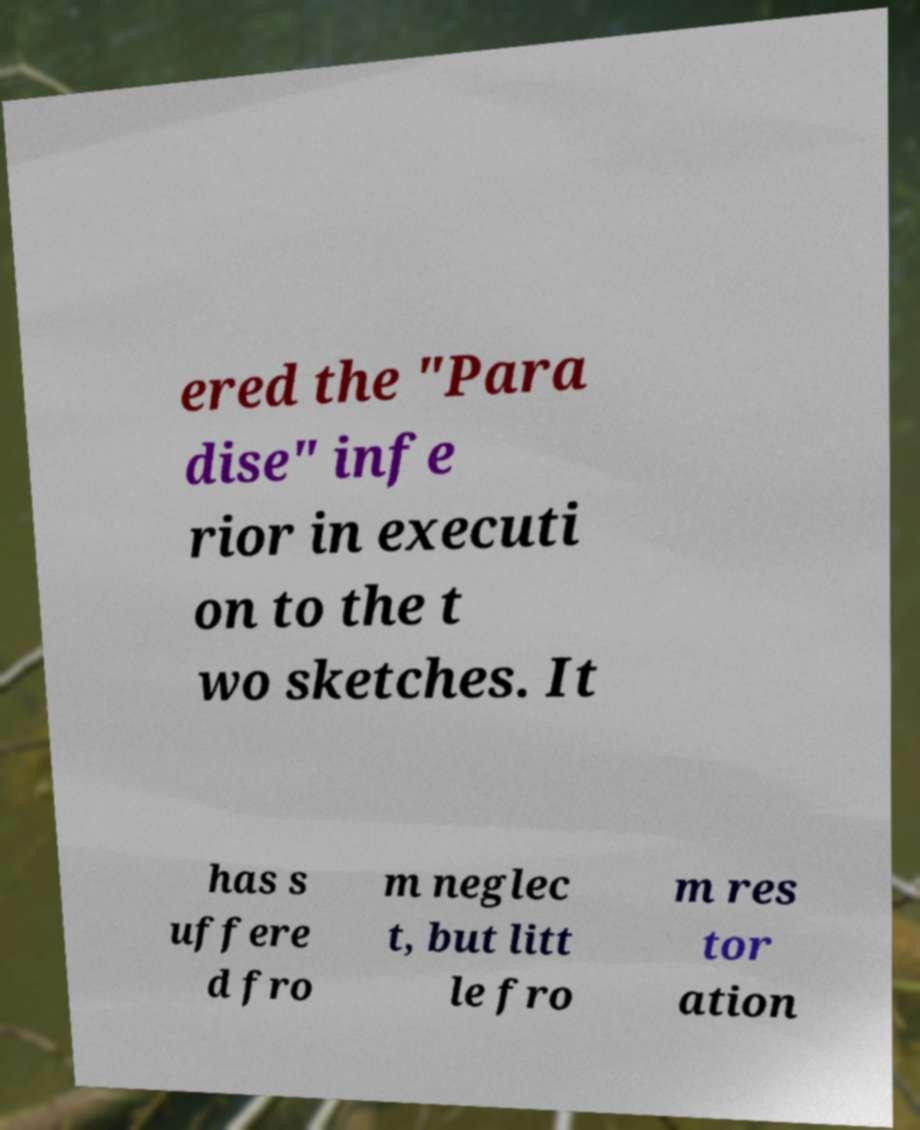I need the written content from this picture converted into text. Can you do that? ered the "Para dise" infe rior in executi on to the t wo sketches. It has s uffere d fro m neglec t, but litt le fro m res tor ation 